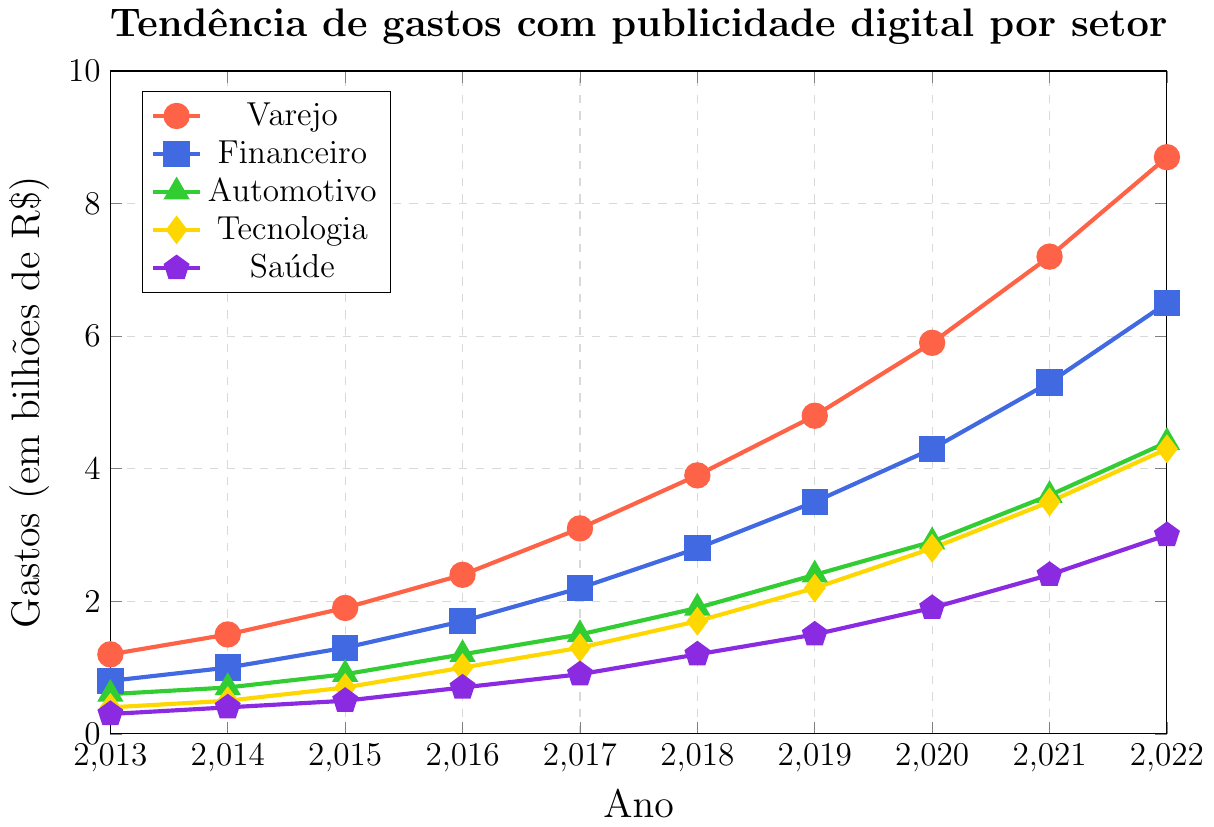What was the total spending on digital advertising across all sectors in 2013? Adding up the spending for each sector in 2013, we get: 1.2 (Varejo) + 0.8 (Financeiro) + 0.6 (Automotivo) + 0.4 (Tecnologia) + 0.3 (Saúde) = 3.3 bilhões de R$.
Answer: 3.3 bilhões de R$ Which sector saw the highest increase in spending from 2013 to 2022? Subtracting the spending in 2013 from the spending in 2022 for each sector: Varejo: 8.7 - 1.2 = 7.5, Financeiro: 6.5 - 0.8 = 5.7, Automotivo: 4.4 - 0.6 = 3.8, Tecnologia: 4.3 - 0.4 = 3.9, Saúde: 3.0 - 0.3 = 2.7. Varejo had the highest increase.
Answer: Varejo In which year did the Tecnologia sector reach the same expenditure level as the Automotivo sector in 2017? In 2017, Automotivo's expenditure was 1.5 bilhões de R$. Checking the Tecnologia values, we see it first matches this in 2019 with 2.2 bilhões de R$.
Answer: 2019 By how much did the spending in the Saúde sector increase from 2016 to 2020? Spending in Saúde in 2016 was 0.7 bilhões de R$. In 2020, it was 1.9 bilhões de R$. The increase is 1.9 - 0.7 = 1.2 bilhões de R$.
Answer: 1.2 bilhões de R$ Rank the sectors by their spending in 2022 from highest to lowest. Checking the expenditures in 2022: Varejo (8.7), Financeiro (6.5), Automotivo (4.4), Tecnologia (4.3), Saúde (3.0). The ranking is: Varejo > Financeiro > Automotivo > Tecnologia > Saúde.
Answer: Varejo, Financeiro, Automotivo, Tecnologia, Saúde Which sector had the smallest relative increase in spending from 2013 to 2022? Calculating the relative increase (expenditure in 2022 / expenditure in 2013): Varejo: 8.7/1.2 ≈ 7.25, Financeiro: 6.5/0.8 ≈ 8.125, Automotivo: 4.4/0.6 ≈ 7.33, Tecnologia: 4.3/0.4 ≈ 10.75, Saúde: 3.0/0.3 ≈ 10. Saúde had the smallest relative increase.
Answer: Varejo If the current trend continues, which sector is most likely to surpass 10 bilhões de R$ first? Varejo is currently the highest with 8.7 bilhões de R$ in 2022. Considering its consistent growth over the years, it's plausible that Varejo will be the first to surpass 10 bilhões de R$.
Answer: Varejo What was the average spending per year for the Financeiro sector from 2013 to 2022? Summing the Financeiro spending from 2013 to 2022: 0.8 + 1.0 + 1.3 + 1.7 + 2.2 + 2.8 + 3.5 + 4.3 + 5.3 + 6.5 = 29.4. Dividing by the number of years (10): 29.4 / 10 = 2.94 bilhões de R$.
Answer: 2.94 bilhões de R$ Which sector showed the steadiest growth in spending over the 10 years? Observing the consistent annual growth without sharp increases or drops for each sector, we see that Tecnologia exhibits a smooth and steady rise from 0.4 in 2013 to 4.3 in 2022.
Answer: Tecnologia 